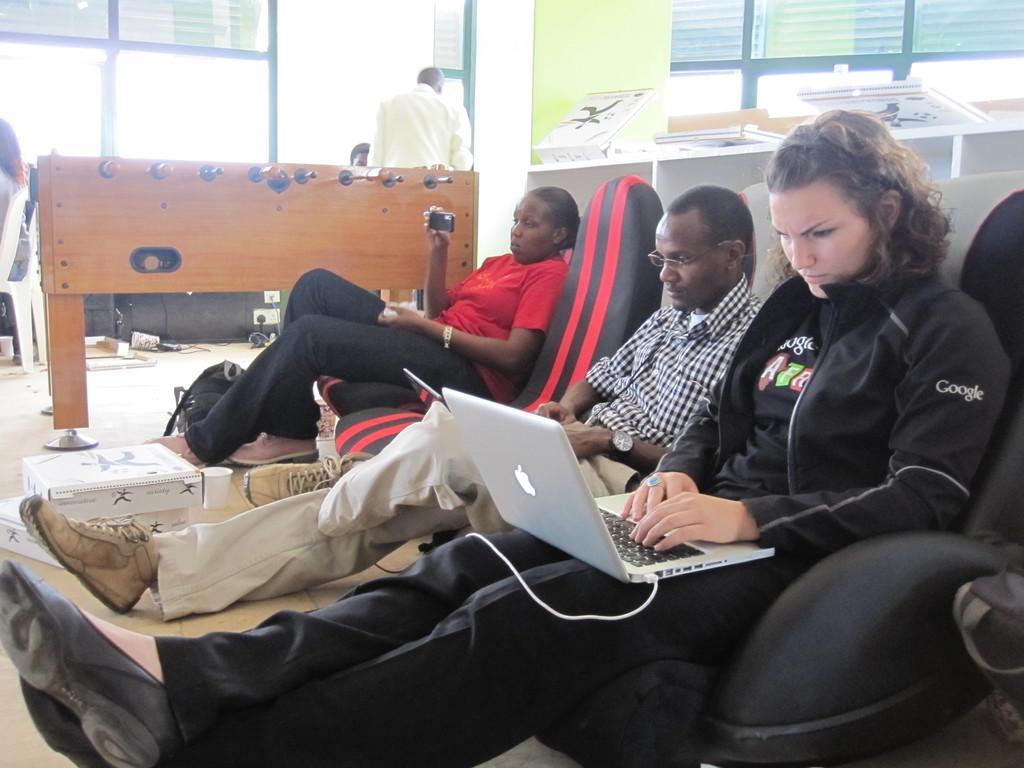How would you summarize this image in a sentence or two? In this image we can see some people sitting on chairs and holding devices in their hands. In the left side of the image we can see boxes and glass placed on the surface. In the center of the image we can see a table with some sticks and a person standing. In the background, we can see boards with some pictures and windows. 